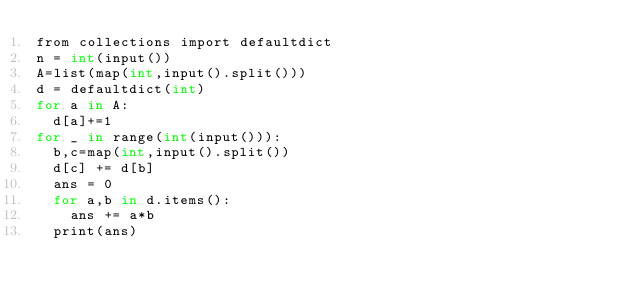Convert code to text. <code><loc_0><loc_0><loc_500><loc_500><_Cython_>from collections import defaultdict
n = int(input())
A=list(map(int,input().split()))
d = defaultdict(int)
for a in A:
  d[a]+=1
for _ in range(int(input())):
  b,c=map(int,input().split())
  d[c] += d[b]
  ans = 0
  for a,b in d.items():
    ans += a*b
  print(ans)</code> 